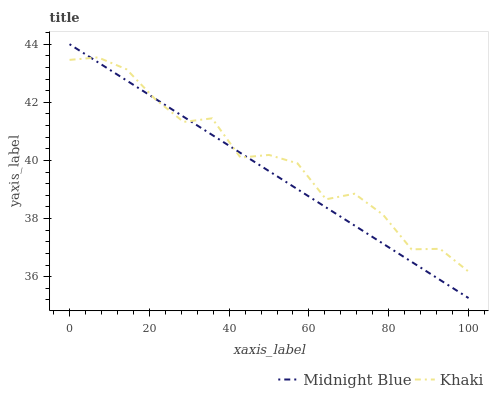Does Midnight Blue have the minimum area under the curve?
Answer yes or no. Yes. Does Khaki have the maximum area under the curve?
Answer yes or no. Yes. Does Midnight Blue have the maximum area under the curve?
Answer yes or no. No. Is Midnight Blue the smoothest?
Answer yes or no. Yes. Is Khaki the roughest?
Answer yes or no. Yes. Is Midnight Blue the roughest?
Answer yes or no. No. Does Midnight Blue have the lowest value?
Answer yes or no. Yes. Does Midnight Blue have the highest value?
Answer yes or no. Yes. Does Khaki intersect Midnight Blue?
Answer yes or no. Yes. Is Khaki less than Midnight Blue?
Answer yes or no. No. Is Khaki greater than Midnight Blue?
Answer yes or no. No. 